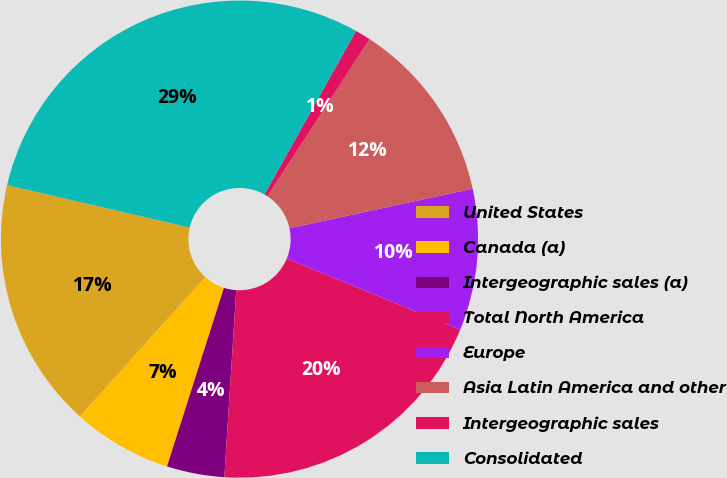Convert chart. <chart><loc_0><loc_0><loc_500><loc_500><pie_chart><fcel>United States<fcel>Canada (a)<fcel>Intergeographic sales (a)<fcel>Total North America<fcel>Europe<fcel>Asia Latin America and other<fcel>Intergeographic sales<fcel>Consolidated<nl><fcel>16.97%<fcel>6.75%<fcel>3.9%<fcel>19.81%<fcel>9.59%<fcel>12.43%<fcel>1.06%<fcel>29.48%<nl></chart> 